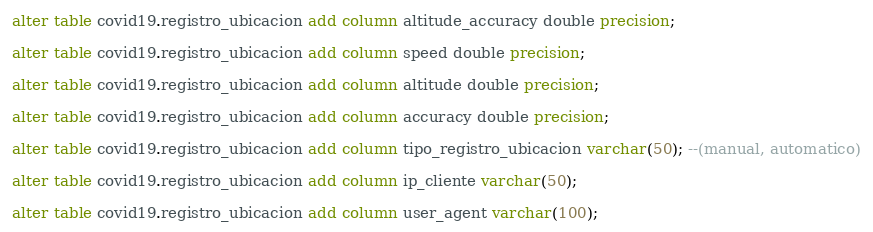<code> <loc_0><loc_0><loc_500><loc_500><_SQL_>alter table covid19.registro_ubicacion add column altitude_accuracy double precision;

alter table covid19.registro_ubicacion add column speed double precision;

alter table covid19.registro_ubicacion add column altitude double precision;

alter table covid19.registro_ubicacion add column accuracy double precision;

alter table covid19.registro_ubicacion add column tipo_registro_ubicacion varchar(50); --(manual, automatico)

alter table covid19.registro_ubicacion add column ip_cliente varchar(50);

alter table covid19.registro_ubicacion add column user_agent varchar(100);</code> 